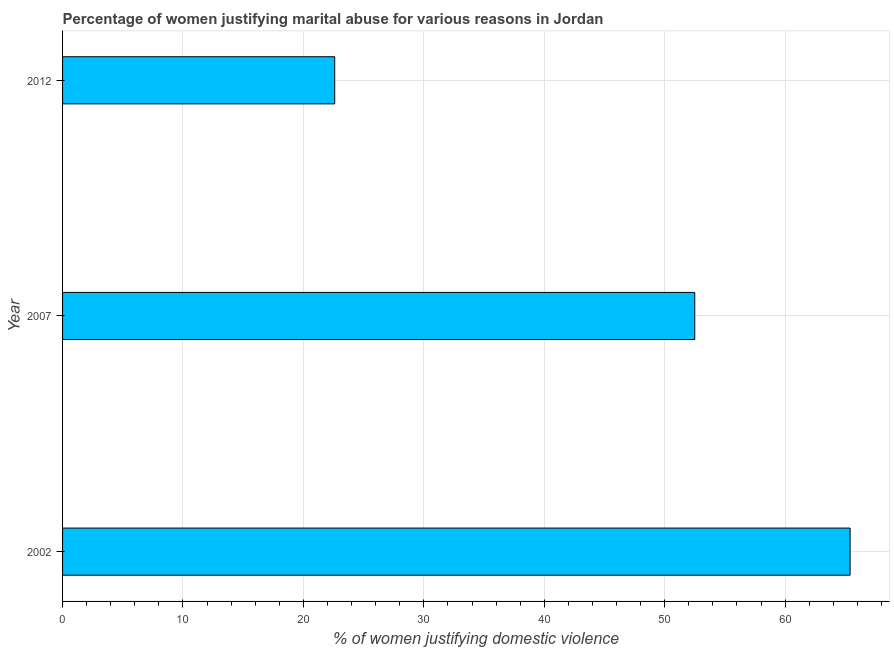Does the graph contain grids?
Your answer should be very brief. Yes. What is the title of the graph?
Your response must be concise. Percentage of women justifying marital abuse for various reasons in Jordan. What is the label or title of the X-axis?
Your response must be concise. % of women justifying domestic violence. What is the percentage of women justifying marital abuse in 2002?
Make the answer very short. 65.4. Across all years, what is the maximum percentage of women justifying marital abuse?
Provide a succinct answer. 65.4. Across all years, what is the minimum percentage of women justifying marital abuse?
Provide a succinct answer. 22.6. In which year was the percentage of women justifying marital abuse maximum?
Make the answer very short. 2002. In which year was the percentage of women justifying marital abuse minimum?
Ensure brevity in your answer.  2012. What is the sum of the percentage of women justifying marital abuse?
Offer a terse response. 140.5. What is the difference between the percentage of women justifying marital abuse in 2002 and 2012?
Your answer should be compact. 42.8. What is the average percentage of women justifying marital abuse per year?
Your answer should be compact. 46.83. What is the median percentage of women justifying marital abuse?
Keep it short and to the point. 52.5. In how many years, is the percentage of women justifying marital abuse greater than 20 %?
Make the answer very short. 3. Do a majority of the years between 2002 and 2007 (inclusive) have percentage of women justifying marital abuse greater than 30 %?
Offer a terse response. Yes. What is the ratio of the percentage of women justifying marital abuse in 2007 to that in 2012?
Make the answer very short. 2.32. Is the percentage of women justifying marital abuse in 2007 less than that in 2012?
Keep it short and to the point. No. What is the difference between the highest and the second highest percentage of women justifying marital abuse?
Give a very brief answer. 12.9. What is the difference between the highest and the lowest percentage of women justifying marital abuse?
Your response must be concise. 42.8. How many bars are there?
Provide a short and direct response. 3. How many years are there in the graph?
Make the answer very short. 3. What is the difference between two consecutive major ticks on the X-axis?
Offer a terse response. 10. Are the values on the major ticks of X-axis written in scientific E-notation?
Offer a very short reply. No. What is the % of women justifying domestic violence in 2002?
Make the answer very short. 65.4. What is the % of women justifying domestic violence of 2007?
Provide a short and direct response. 52.5. What is the % of women justifying domestic violence in 2012?
Give a very brief answer. 22.6. What is the difference between the % of women justifying domestic violence in 2002 and 2007?
Your answer should be very brief. 12.9. What is the difference between the % of women justifying domestic violence in 2002 and 2012?
Make the answer very short. 42.8. What is the difference between the % of women justifying domestic violence in 2007 and 2012?
Your answer should be compact. 29.9. What is the ratio of the % of women justifying domestic violence in 2002 to that in 2007?
Your answer should be compact. 1.25. What is the ratio of the % of women justifying domestic violence in 2002 to that in 2012?
Ensure brevity in your answer.  2.89. What is the ratio of the % of women justifying domestic violence in 2007 to that in 2012?
Provide a succinct answer. 2.32. 